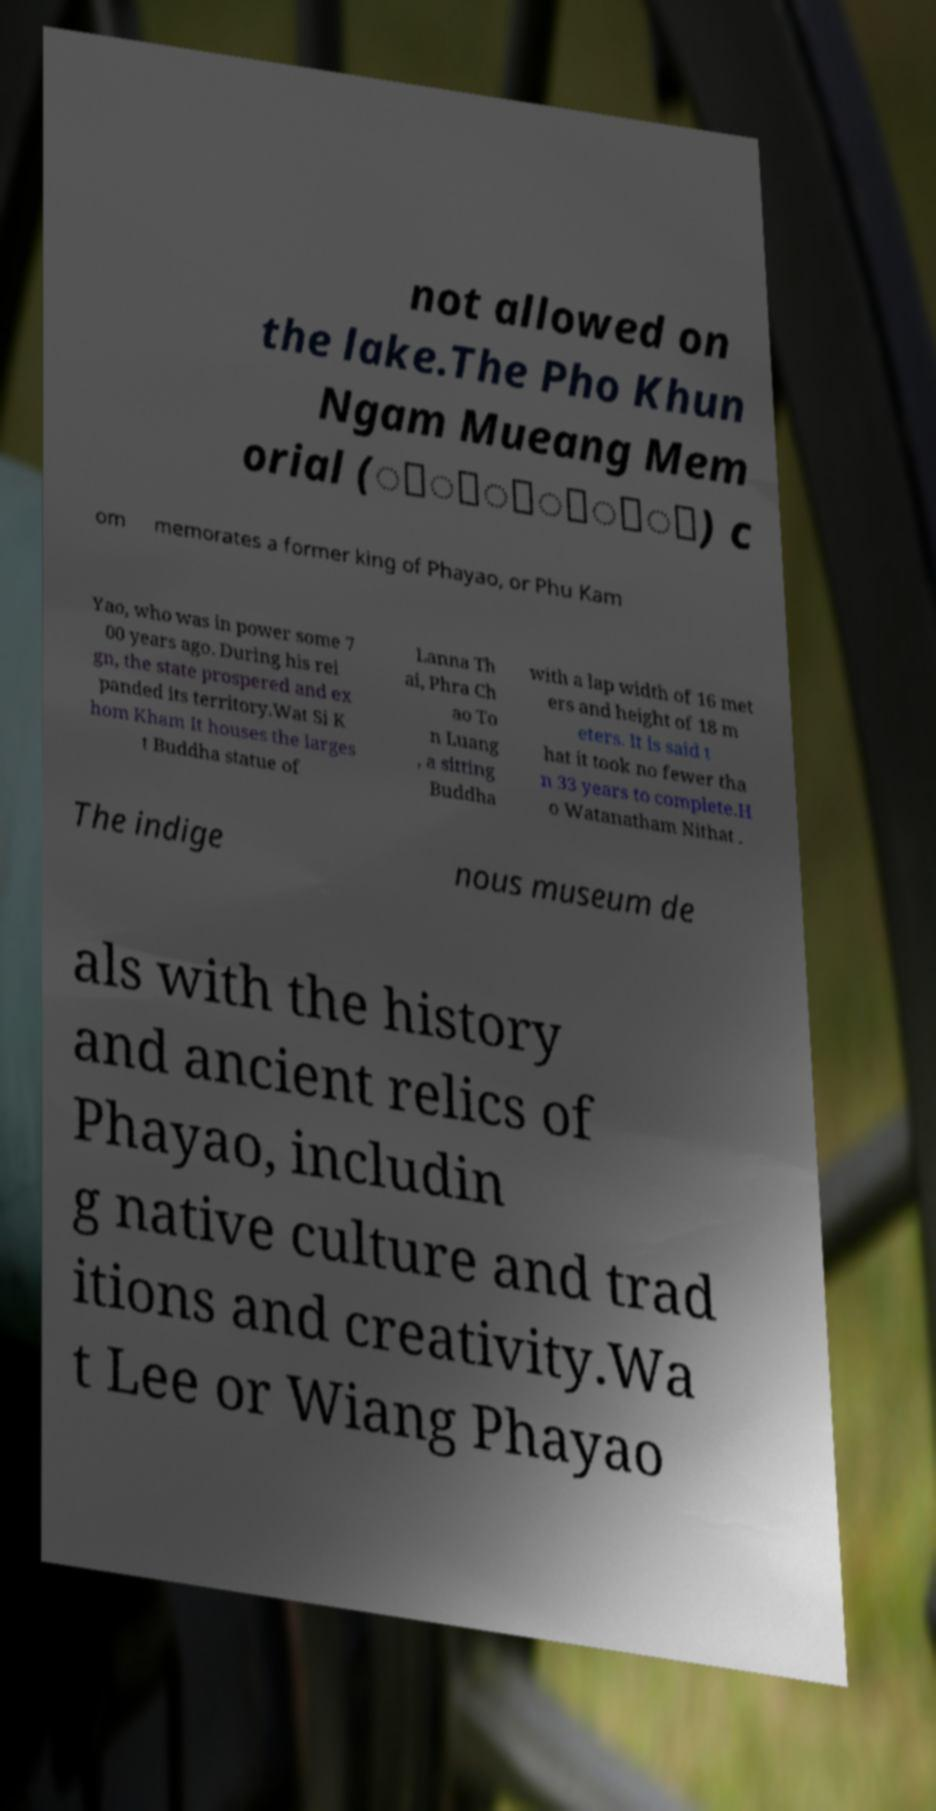Can you read and provide the text displayed in the image?This photo seems to have some interesting text. Can you extract and type it out for me? not allowed on the lake.The Pho Khun Ngam Mueang Mem orial (ุี์ุ่ื) c om memorates a former king of Phayao, or Phu Kam Yao, who was in power some 7 00 years ago. During his rei gn, the state prospered and ex panded its territory.Wat Si K hom Kham It houses the larges t Buddha statue of Lanna Th ai, Phra Ch ao To n Luang , a sitting Buddha with a lap width of 16 met ers and height of 18 m eters. It is said t hat it took no fewer tha n 33 years to complete.H o Watanatham Nithat . The indige nous museum de als with the history and ancient relics of Phayao, includin g native culture and trad itions and creativity.Wa t Lee or Wiang Phayao 